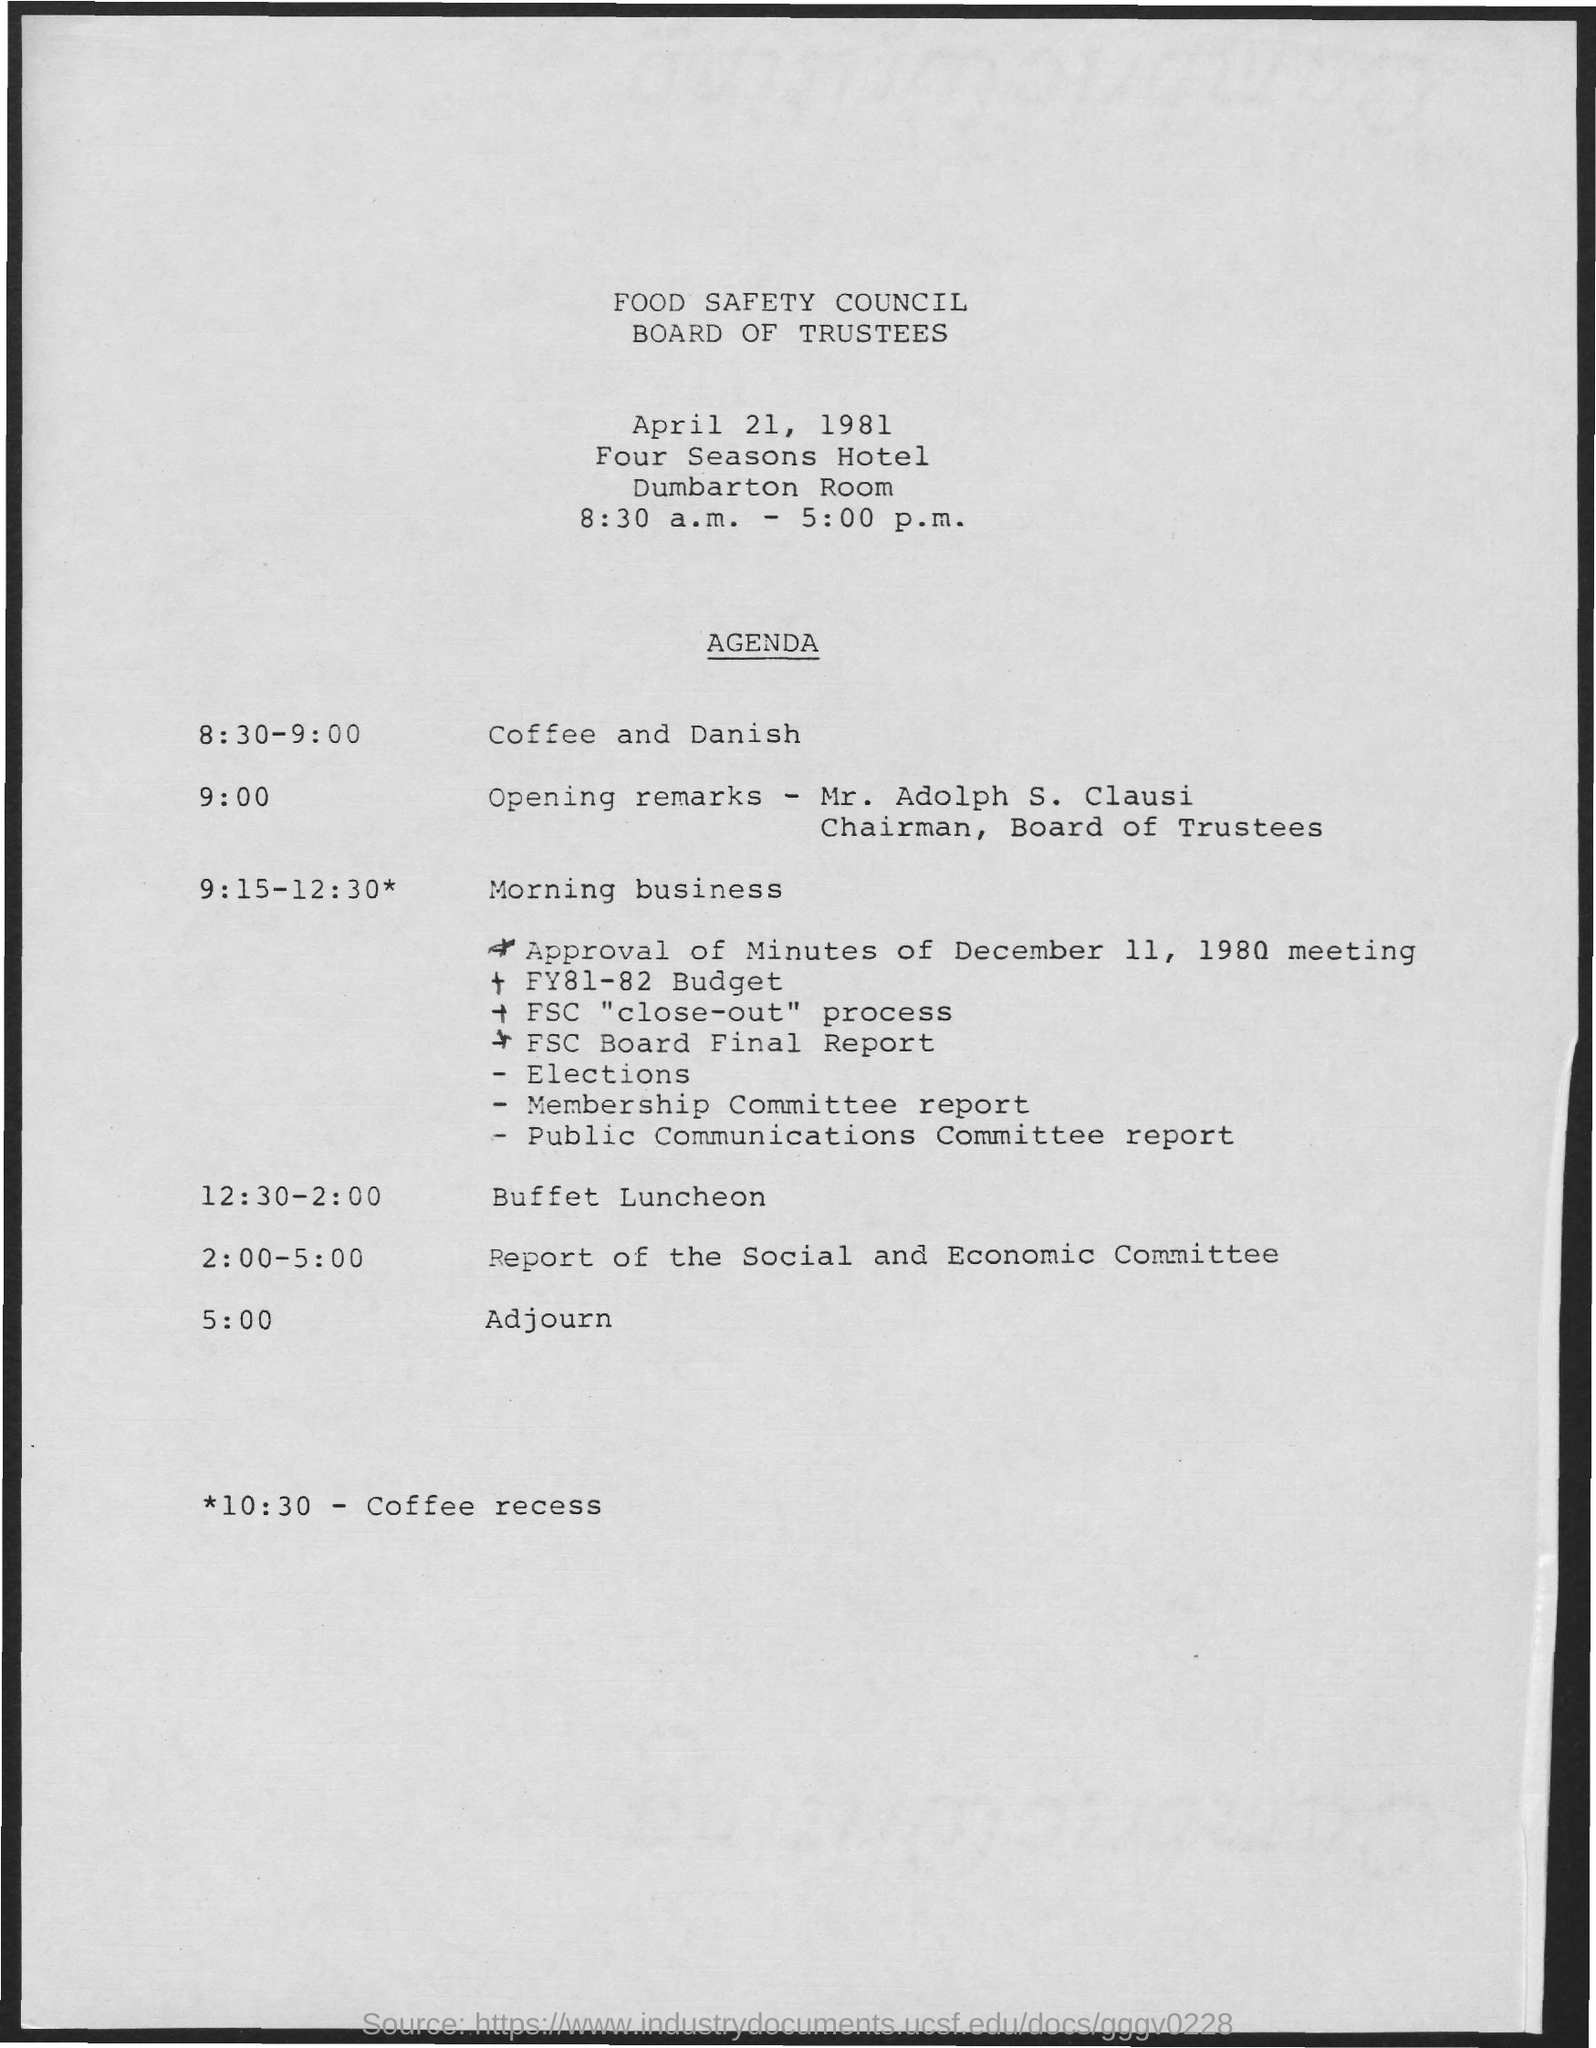What is the heading of the document?
Offer a very short reply. FOOD SAFETY COUNCIL BOARD OF TRUSTEES. What is the schedule for 10:30?
Provide a short and direct response. Coffee recess. 